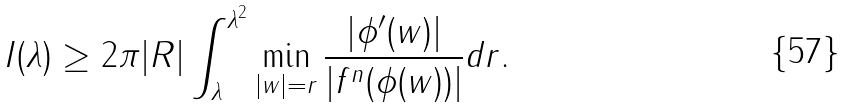<formula> <loc_0><loc_0><loc_500><loc_500>I ( \lambda ) \geq 2 \pi | R | \int _ { \lambda } ^ { \lambda ^ { 2 } } \min _ { | w | = r } \frac { | \phi ^ { \prime } ( w ) | } { | f ^ { n } ( \phi ( w ) ) | } d r .</formula> 